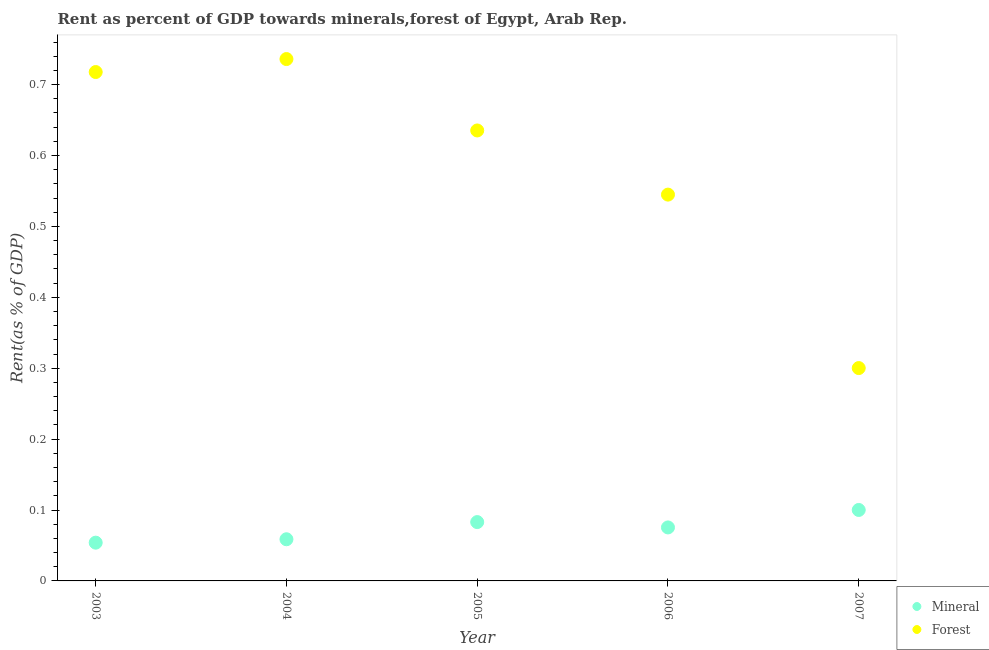Is the number of dotlines equal to the number of legend labels?
Offer a very short reply. Yes. What is the mineral rent in 2005?
Keep it short and to the point. 0.08. Across all years, what is the maximum mineral rent?
Give a very brief answer. 0.1. Across all years, what is the minimum mineral rent?
Your response must be concise. 0.05. What is the total forest rent in the graph?
Your response must be concise. 2.93. What is the difference between the mineral rent in 2003 and that in 2007?
Your answer should be very brief. -0.05. What is the difference between the forest rent in 2006 and the mineral rent in 2005?
Provide a short and direct response. 0.46. What is the average mineral rent per year?
Provide a short and direct response. 0.07. In the year 2005, what is the difference between the mineral rent and forest rent?
Your answer should be very brief. -0.55. What is the ratio of the mineral rent in 2003 to that in 2004?
Provide a succinct answer. 0.92. What is the difference between the highest and the second highest forest rent?
Keep it short and to the point. 0.02. What is the difference between the highest and the lowest forest rent?
Keep it short and to the point. 0.44. Is the forest rent strictly less than the mineral rent over the years?
Offer a terse response. No. How many dotlines are there?
Your response must be concise. 2. How many years are there in the graph?
Your answer should be very brief. 5. What is the difference between two consecutive major ticks on the Y-axis?
Your answer should be compact. 0.1. Are the values on the major ticks of Y-axis written in scientific E-notation?
Provide a short and direct response. No. Does the graph contain grids?
Your response must be concise. No. How many legend labels are there?
Your answer should be very brief. 2. How are the legend labels stacked?
Ensure brevity in your answer.  Vertical. What is the title of the graph?
Offer a very short reply. Rent as percent of GDP towards minerals,forest of Egypt, Arab Rep. Does "Goods and services" appear as one of the legend labels in the graph?
Your answer should be compact. No. What is the label or title of the Y-axis?
Offer a very short reply. Rent(as % of GDP). What is the Rent(as % of GDP) of Mineral in 2003?
Provide a short and direct response. 0.05. What is the Rent(as % of GDP) of Forest in 2003?
Your answer should be compact. 0.72. What is the Rent(as % of GDP) of Mineral in 2004?
Your response must be concise. 0.06. What is the Rent(as % of GDP) in Forest in 2004?
Offer a terse response. 0.74. What is the Rent(as % of GDP) of Mineral in 2005?
Your response must be concise. 0.08. What is the Rent(as % of GDP) of Forest in 2005?
Your answer should be very brief. 0.64. What is the Rent(as % of GDP) of Mineral in 2006?
Ensure brevity in your answer.  0.08. What is the Rent(as % of GDP) in Forest in 2006?
Ensure brevity in your answer.  0.54. What is the Rent(as % of GDP) of Mineral in 2007?
Provide a succinct answer. 0.1. What is the Rent(as % of GDP) in Forest in 2007?
Your response must be concise. 0.3. Across all years, what is the maximum Rent(as % of GDP) in Mineral?
Offer a very short reply. 0.1. Across all years, what is the maximum Rent(as % of GDP) in Forest?
Your response must be concise. 0.74. Across all years, what is the minimum Rent(as % of GDP) of Mineral?
Keep it short and to the point. 0.05. Across all years, what is the minimum Rent(as % of GDP) of Forest?
Offer a terse response. 0.3. What is the total Rent(as % of GDP) in Mineral in the graph?
Provide a succinct answer. 0.37. What is the total Rent(as % of GDP) of Forest in the graph?
Your answer should be compact. 2.93. What is the difference between the Rent(as % of GDP) of Mineral in 2003 and that in 2004?
Provide a short and direct response. -0. What is the difference between the Rent(as % of GDP) of Forest in 2003 and that in 2004?
Your answer should be compact. -0.02. What is the difference between the Rent(as % of GDP) in Mineral in 2003 and that in 2005?
Keep it short and to the point. -0.03. What is the difference between the Rent(as % of GDP) in Forest in 2003 and that in 2005?
Your answer should be compact. 0.08. What is the difference between the Rent(as % of GDP) of Mineral in 2003 and that in 2006?
Ensure brevity in your answer.  -0.02. What is the difference between the Rent(as % of GDP) in Forest in 2003 and that in 2006?
Your response must be concise. 0.17. What is the difference between the Rent(as % of GDP) in Mineral in 2003 and that in 2007?
Offer a terse response. -0.05. What is the difference between the Rent(as % of GDP) in Forest in 2003 and that in 2007?
Provide a short and direct response. 0.42. What is the difference between the Rent(as % of GDP) in Mineral in 2004 and that in 2005?
Offer a terse response. -0.02. What is the difference between the Rent(as % of GDP) in Forest in 2004 and that in 2005?
Provide a short and direct response. 0.1. What is the difference between the Rent(as % of GDP) of Mineral in 2004 and that in 2006?
Ensure brevity in your answer.  -0.02. What is the difference between the Rent(as % of GDP) of Forest in 2004 and that in 2006?
Offer a very short reply. 0.19. What is the difference between the Rent(as % of GDP) in Mineral in 2004 and that in 2007?
Offer a terse response. -0.04. What is the difference between the Rent(as % of GDP) in Forest in 2004 and that in 2007?
Ensure brevity in your answer.  0.44. What is the difference between the Rent(as % of GDP) in Mineral in 2005 and that in 2006?
Ensure brevity in your answer.  0.01. What is the difference between the Rent(as % of GDP) of Forest in 2005 and that in 2006?
Offer a terse response. 0.09. What is the difference between the Rent(as % of GDP) of Mineral in 2005 and that in 2007?
Make the answer very short. -0.02. What is the difference between the Rent(as % of GDP) in Forest in 2005 and that in 2007?
Your answer should be very brief. 0.34. What is the difference between the Rent(as % of GDP) in Mineral in 2006 and that in 2007?
Ensure brevity in your answer.  -0.02. What is the difference between the Rent(as % of GDP) of Forest in 2006 and that in 2007?
Provide a short and direct response. 0.24. What is the difference between the Rent(as % of GDP) of Mineral in 2003 and the Rent(as % of GDP) of Forest in 2004?
Give a very brief answer. -0.68. What is the difference between the Rent(as % of GDP) in Mineral in 2003 and the Rent(as % of GDP) in Forest in 2005?
Ensure brevity in your answer.  -0.58. What is the difference between the Rent(as % of GDP) in Mineral in 2003 and the Rent(as % of GDP) in Forest in 2006?
Your response must be concise. -0.49. What is the difference between the Rent(as % of GDP) of Mineral in 2003 and the Rent(as % of GDP) of Forest in 2007?
Offer a very short reply. -0.25. What is the difference between the Rent(as % of GDP) in Mineral in 2004 and the Rent(as % of GDP) in Forest in 2005?
Provide a succinct answer. -0.58. What is the difference between the Rent(as % of GDP) of Mineral in 2004 and the Rent(as % of GDP) of Forest in 2006?
Offer a very short reply. -0.49. What is the difference between the Rent(as % of GDP) in Mineral in 2004 and the Rent(as % of GDP) in Forest in 2007?
Provide a short and direct response. -0.24. What is the difference between the Rent(as % of GDP) of Mineral in 2005 and the Rent(as % of GDP) of Forest in 2006?
Make the answer very short. -0.46. What is the difference between the Rent(as % of GDP) in Mineral in 2005 and the Rent(as % of GDP) in Forest in 2007?
Offer a very short reply. -0.22. What is the difference between the Rent(as % of GDP) of Mineral in 2006 and the Rent(as % of GDP) of Forest in 2007?
Offer a terse response. -0.22. What is the average Rent(as % of GDP) of Mineral per year?
Your answer should be compact. 0.07. What is the average Rent(as % of GDP) of Forest per year?
Your answer should be compact. 0.59. In the year 2003, what is the difference between the Rent(as % of GDP) in Mineral and Rent(as % of GDP) in Forest?
Your answer should be compact. -0.66. In the year 2004, what is the difference between the Rent(as % of GDP) in Mineral and Rent(as % of GDP) in Forest?
Your answer should be compact. -0.68. In the year 2005, what is the difference between the Rent(as % of GDP) of Mineral and Rent(as % of GDP) of Forest?
Give a very brief answer. -0.55. In the year 2006, what is the difference between the Rent(as % of GDP) of Mineral and Rent(as % of GDP) of Forest?
Offer a terse response. -0.47. In the year 2007, what is the difference between the Rent(as % of GDP) of Mineral and Rent(as % of GDP) of Forest?
Give a very brief answer. -0.2. What is the ratio of the Rent(as % of GDP) in Mineral in 2003 to that in 2004?
Offer a very short reply. 0.92. What is the ratio of the Rent(as % of GDP) of Forest in 2003 to that in 2004?
Give a very brief answer. 0.98. What is the ratio of the Rent(as % of GDP) of Mineral in 2003 to that in 2005?
Give a very brief answer. 0.65. What is the ratio of the Rent(as % of GDP) in Forest in 2003 to that in 2005?
Your response must be concise. 1.13. What is the ratio of the Rent(as % of GDP) of Mineral in 2003 to that in 2006?
Keep it short and to the point. 0.72. What is the ratio of the Rent(as % of GDP) in Forest in 2003 to that in 2006?
Provide a short and direct response. 1.32. What is the ratio of the Rent(as % of GDP) in Mineral in 2003 to that in 2007?
Give a very brief answer. 0.54. What is the ratio of the Rent(as % of GDP) in Forest in 2003 to that in 2007?
Make the answer very short. 2.39. What is the ratio of the Rent(as % of GDP) of Mineral in 2004 to that in 2005?
Offer a very short reply. 0.71. What is the ratio of the Rent(as % of GDP) of Forest in 2004 to that in 2005?
Provide a short and direct response. 1.16. What is the ratio of the Rent(as % of GDP) in Mineral in 2004 to that in 2006?
Ensure brevity in your answer.  0.78. What is the ratio of the Rent(as % of GDP) of Forest in 2004 to that in 2006?
Make the answer very short. 1.35. What is the ratio of the Rent(as % of GDP) in Mineral in 2004 to that in 2007?
Your answer should be compact. 0.59. What is the ratio of the Rent(as % of GDP) in Forest in 2004 to that in 2007?
Your answer should be compact. 2.45. What is the ratio of the Rent(as % of GDP) in Forest in 2005 to that in 2006?
Your answer should be compact. 1.17. What is the ratio of the Rent(as % of GDP) in Mineral in 2005 to that in 2007?
Your response must be concise. 0.83. What is the ratio of the Rent(as % of GDP) in Forest in 2005 to that in 2007?
Your answer should be very brief. 2.12. What is the ratio of the Rent(as % of GDP) in Mineral in 2006 to that in 2007?
Keep it short and to the point. 0.75. What is the ratio of the Rent(as % of GDP) of Forest in 2006 to that in 2007?
Give a very brief answer. 1.81. What is the difference between the highest and the second highest Rent(as % of GDP) of Mineral?
Your response must be concise. 0.02. What is the difference between the highest and the second highest Rent(as % of GDP) in Forest?
Your answer should be compact. 0.02. What is the difference between the highest and the lowest Rent(as % of GDP) in Mineral?
Your response must be concise. 0.05. What is the difference between the highest and the lowest Rent(as % of GDP) in Forest?
Give a very brief answer. 0.44. 